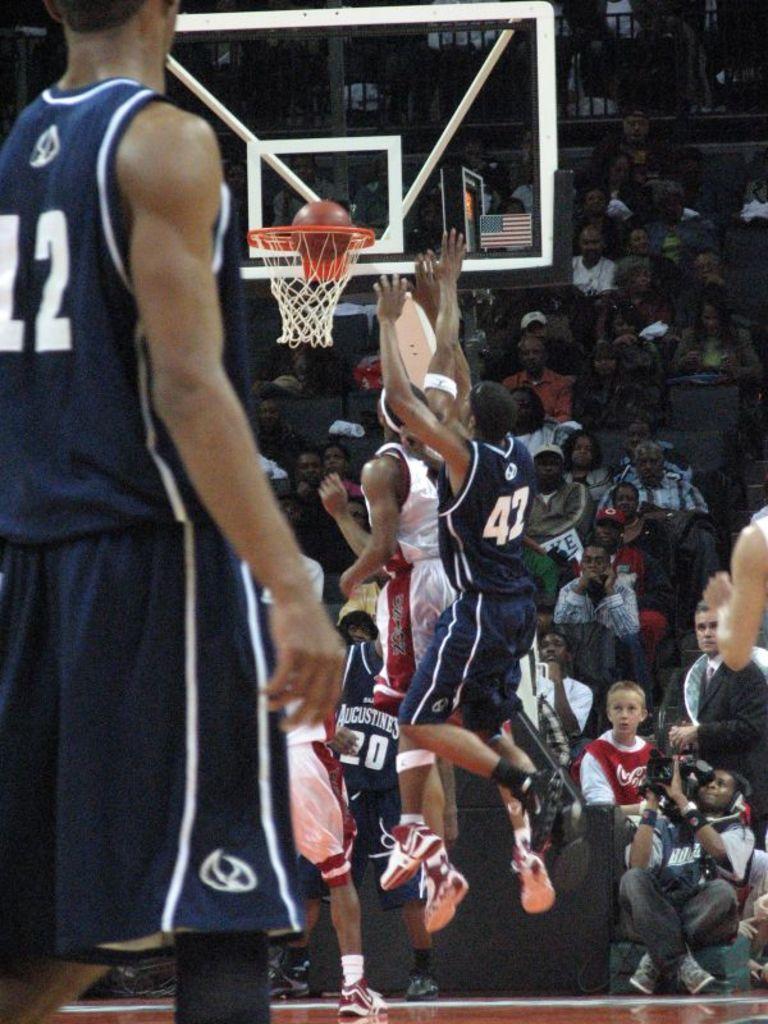Can you describe this image briefly? In this image I can see some people are playing the basketball. In the background, I can see some people are sitting. 